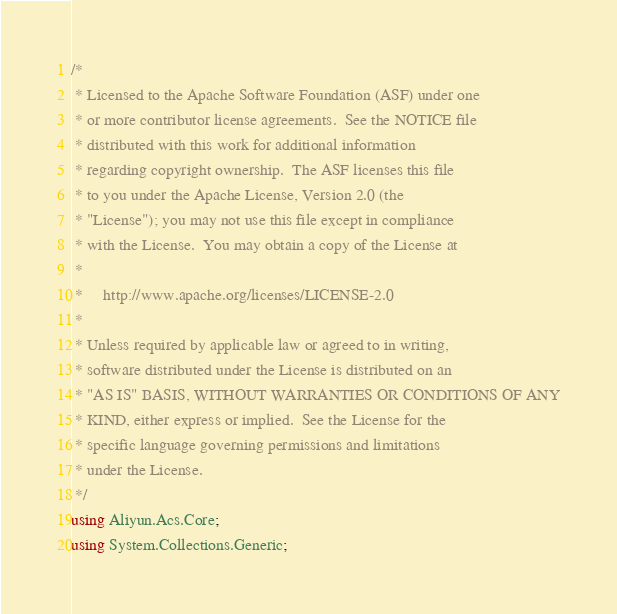Convert code to text. <code><loc_0><loc_0><loc_500><loc_500><_C#_>/*
 * Licensed to the Apache Software Foundation (ASF) under one
 * or more contributor license agreements.  See the NOTICE file
 * distributed with this work for additional information
 * regarding copyright ownership.  The ASF licenses this file
 * to you under the Apache License, Version 2.0 (the
 * "License"); you may not use this file except in compliance
 * with the License.  You may obtain a copy of the License at
 *
 *     http://www.apache.org/licenses/LICENSE-2.0
 *
 * Unless required by applicable law or agreed to in writing,
 * software distributed under the License is distributed on an
 * "AS IS" BASIS, WITHOUT WARRANTIES OR CONDITIONS OF ANY
 * KIND, either express or implied.  See the License for the
 * specific language governing permissions and limitations
 * under the License.
 */
using Aliyun.Acs.Core;
using System.Collections.Generic;
</code> 